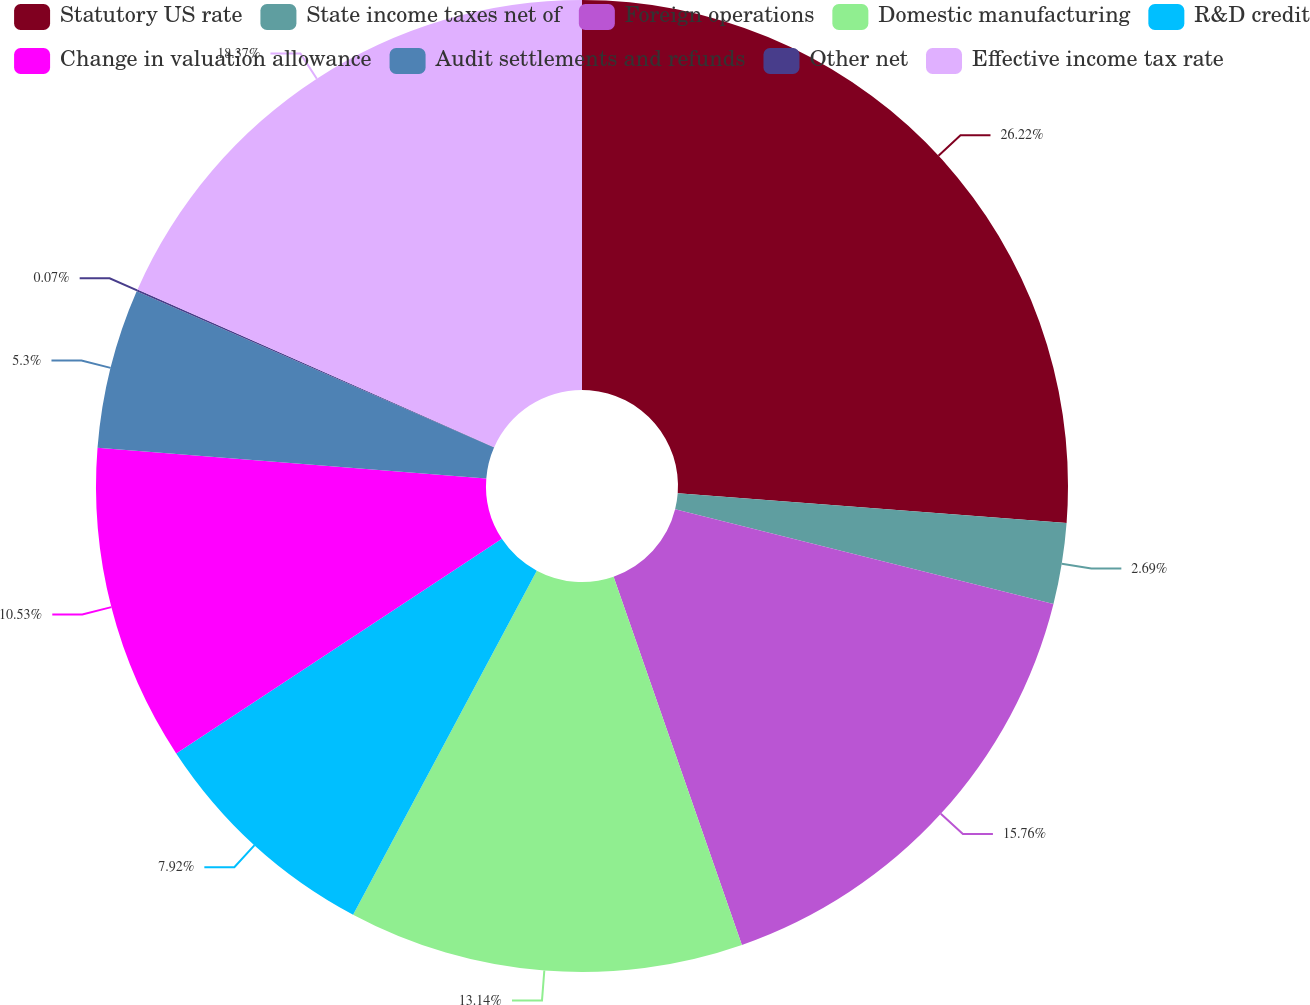Convert chart. <chart><loc_0><loc_0><loc_500><loc_500><pie_chart><fcel>Statutory US rate<fcel>State income taxes net of<fcel>Foreign operations<fcel>Domestic manufacturing<fcel>R&D credit<fcel>Change in valuation allowance<fcel>Audit settlements and refunds<fcel>Other net<fcel>Effective income tax rate<nl><fcel>26.21%<fcel>2.69%<fcel>15.76%<fcel>13.14%<fcel>7.92%<fcel>10.53%<fcel>5.3%<fcel>0.07%<fcel>18.37%<nl></chart> 